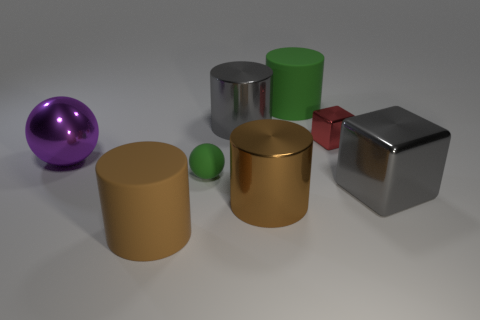Is there any other thing that has the same size as the purple sphere?
Provide a succinct answer. Yes. What material is the green cylinder that is the same size as the purple thing?
Offer a terse response. Rubber. There is a green thing that is the same size as the purple ball; what shape is it?
Your answer should be compact. Cylinder. What color is the thing that is both in front of the purple ball and on the right side of the green cylinder?
Provide a succinct answer. Gray. There is a big metal cube; is its color the same as the big shiny cylinder that is behind the red shiny block?
Your answer should be compact. Yes. Are there any tiny red things that are right of the large gray shiny thing that is to the right of the matte cylinder behind the green ball?
Provide a short and direct response. No. What shape is the big brown thing that is made of the same material as the big purple thing?
Make the answer very short. Cylinder. Is there any other thing that has the same shape as the tiny rubber thing?
Give a very brief answer. Yes. The brown rubber object has what shape?
Offer a terse response. Cylinder. There is a green matte object that is behind the metal ball; is its shape the same as the tiny matte object?
Your answer should be very brief. No. 